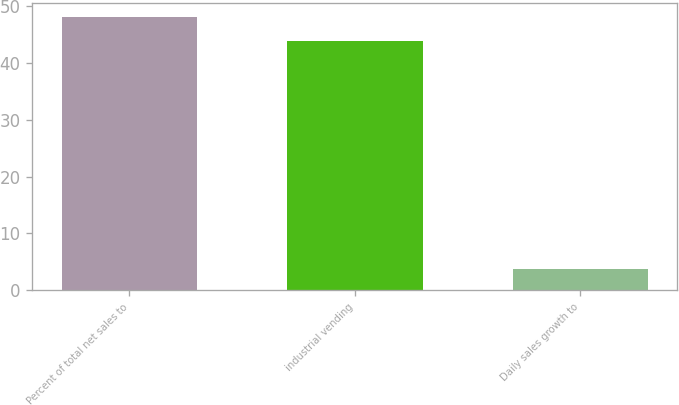Convert chart. <chart><loc_0><loc_0><loc_500><loc_500><bar_chart><fcel>Percent of total net sales to<fcel>industrial vending<fcel>Daily sales growth to<nl><fcel>48.14<fcel>43.9<fcel>3.7<nl></chart> 